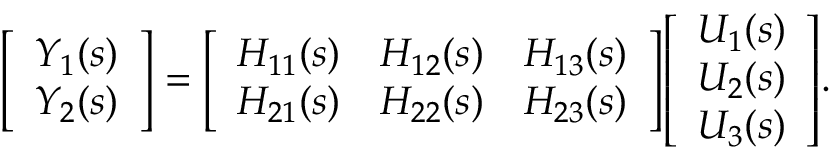<formula> <loc_0><loc_0><loc_500><loc_500>{ \left [ \begin{array} { l } { Y _ { 1 } ( s ) } \\ { Y _ { 2 } ( s ) } \end{array} \right ] } = { \left [ \begin{array} { l l l } { H _ { 1 1 } ( s ) } & { H _ { 1 2 } ( s ) } & { H _ { 1 3 } ( s ) } \\ { H _ { 2 1 } ( s ) } & { H _ { 2 2 } ( s ) } & { H _ { 2 3 } ( s ) } \end{array} \right ] } { \left [ \begin{array} { l } { U _ { 1 } ( s ) } \\ { U _ { 2 } ( s ) } \\ { U _ { 3 } ( s ) } \end{array} \right ] } .</formula> 